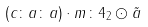<formula> <loc_0><loc_0><loc_500><loc_500>( c \colon a \colon a ) \cdot m \colon 4 _ { 2 } \odot \tilde { a }</formula> 